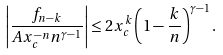<formula> <loc_0><loc_0><loc_500><loc_500>\left | \frac { f _ { n - k } } { A x _ { c } ^ { - n } n ^ { \gamma - 1 } } \right | \leq 2 x _ { c } ^ { k } \left ( 1 - \frac { k } { n } \right ) ^ { \gamma - 1 } .</formula> 